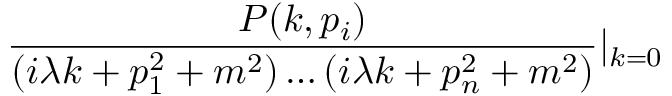<formula> <loc_0><loc_0><loc_500><loc_500>\frac { P ( k , p _ { i } ) } { ( i \lambda k + p _ { 1 } ^ { 2 } + m ^ { 2 } ) \dots ( i \lambda k + p _ { n } ^ { 2 } + m ^ { 2 } ) } | _ { k = 0 }</formula> 